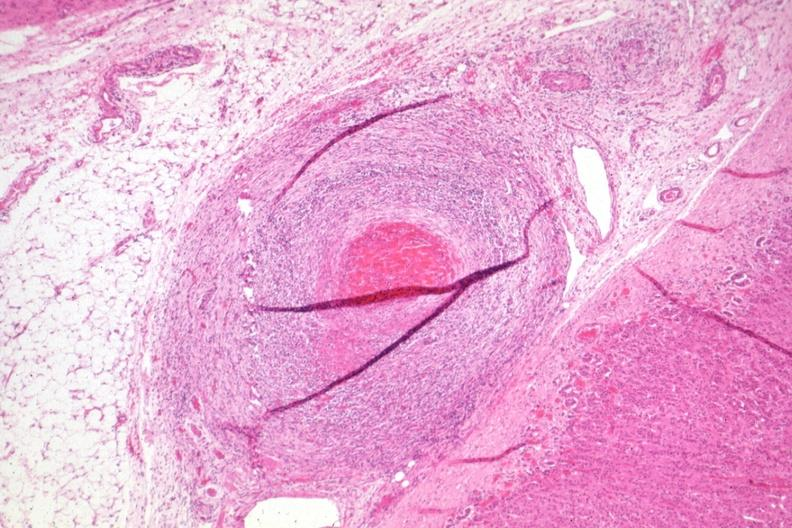what is present?
Answer the question using a single word or phrase. Polyarteritis nodosa 